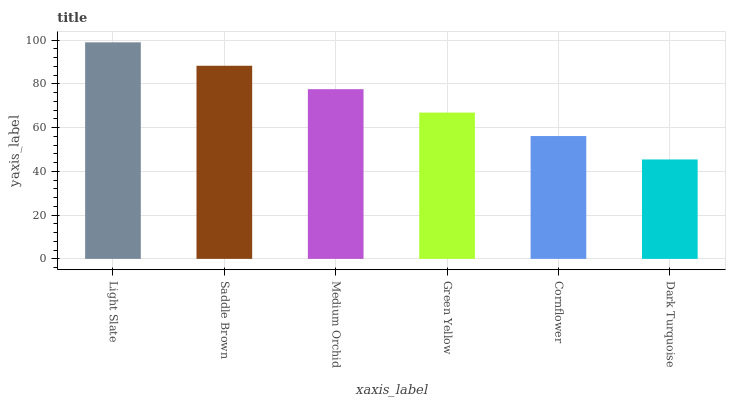Is Dark Turquoise the minimum?
Answer yes or no. Yes. Is Light Slate the maximum?
Answer yes or no. Yes. Is Saddle Brown the minimum?
Answer yes or no. No. Is Saddle Brown the maximum?
Answer yes or no. No. Is Light Slate greater than Saddle Brown?
Answer yes or no. Yes. Is Saddle Brown less than Light Slate?
Answer yes or no. Yes. Is Saddle Brown greater than Light Slate?
Answer yes or no. No. Is Light Slate less than Saddle Brown?
Answer yes or no. No. Is Medium Orchid the high median?
Answer yes or no. Yes. Is Green Yellow the low median?
Answer yes or no. Yes. Is Green Yellow the high median?
Answer yes or no. No. Is Light Slate the low median?
Answer yes or no. No. 